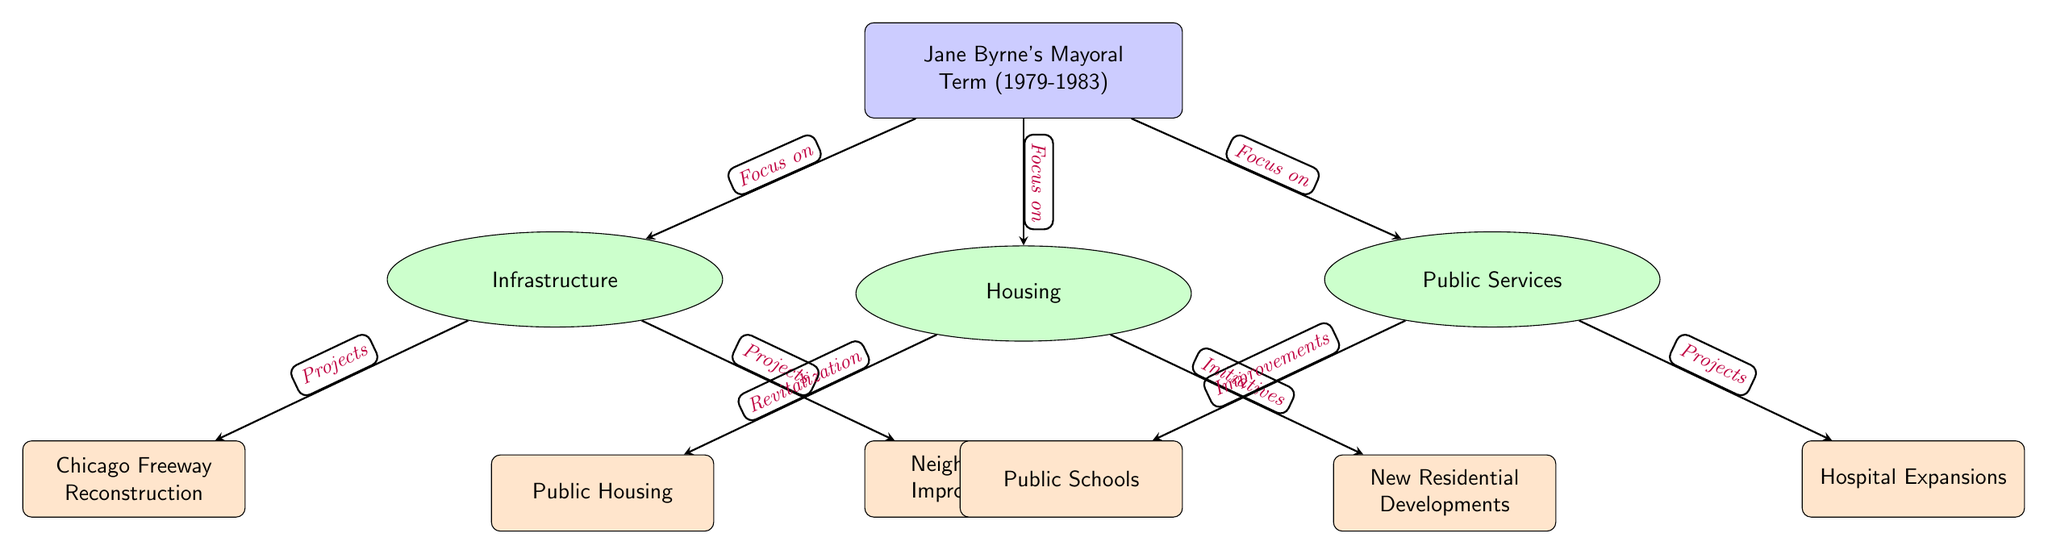What is the main theme of the diagram? The diagram centers around urban development projects during Jane Byrne's mayoral term, highlighting infrastructure, housing, and public services. The main node explicitly states, "Jane Byrne's Mayoral Term (1979-1983)," which serves as the focal point for the categories below it.
Answer: Jane Byrne's Mayoral Term (1979-1983) How many categories are in the diagram? The diagram contains three main categories: Infrastructure, Housing, and Public Services. These categories are indicated by the category nodes positioned below the main node.
Answer: 3 What type of improvements are shown under Public Services? Under Public Services, two subcategories indicate the types of improvements: "Public Schools" and "Hospital Expansions." These subcategories are connected to the Public Services category node, indicating what specific improvements were focused on.
Answer: Public Schools; Hospital Expansions Which subcategory is related to revitalization efforts in housing? The subcategory related to revitalization efforts in housing is "Public Housing." The diagram shows that this subcategory stems from the Housing category, indicating a specific focus on revitalizing public housing during that time.
Answer: Public Housing What projects are listed under the Infrastructure category? The Infrastructure category lists two specific projects: "Chicago Freeway Reconstruction" and "Neighborhood Improvements." These represent the types of infrastructure projects that were initiated during the mayoral term, emphasized by their connections stemming from the Infrastructure category.
Answer: Chicago Freeway Reconstruction; Neighborhood Improvements Which two areas of focus are connected under Housing? The two areas of focus connected under Housing are "Public Housing" and "New Residential Developments." The diagram denotes these as initiatives that were pursued to address housing concerns during Byrne's term, reflecting a dual focus on revitalization and new development.
Answer: Public Housing; New Residential Developments What is the relationship between Public Services and Housing in this diagram? The relationship between Public Services and Housing is that both are key areas of focus during Jane Byrne's mayoral term. They are separate categories stemming from the main node but indicate parallel efforts to improve urban life through housing initiatives and public service enhancements.
Answer: Focus on urban improvement How many subcategories are connected to the Infrastructure category? The diagram shows two subcategories connected to the Infrastructure category: "Chicago Freeway Reconstruction" and "Neighborhood Improvements." This indicates a focused effort on infrastructure development with specified projects.
Answer: 2 What indicates the projects within the Infrastructure category? The projects within the Infrastructure category are indicated by the arrows labeled “Projects” that connect the Infrastructure node to its subcategories. This clarifies that these specific projects are initiatives undertaken during that era.
Answer: Projects What type of initiatives are described under Housing? The housing initiatives are described as "Revitalization" and "Initiatives," connected to the respective subcategories "Public Housing" and "New Residential Developments." This classification displays the dual approach of addressing existing housing issues and creating new developments.
Answer: Revitalization; Initiatives 